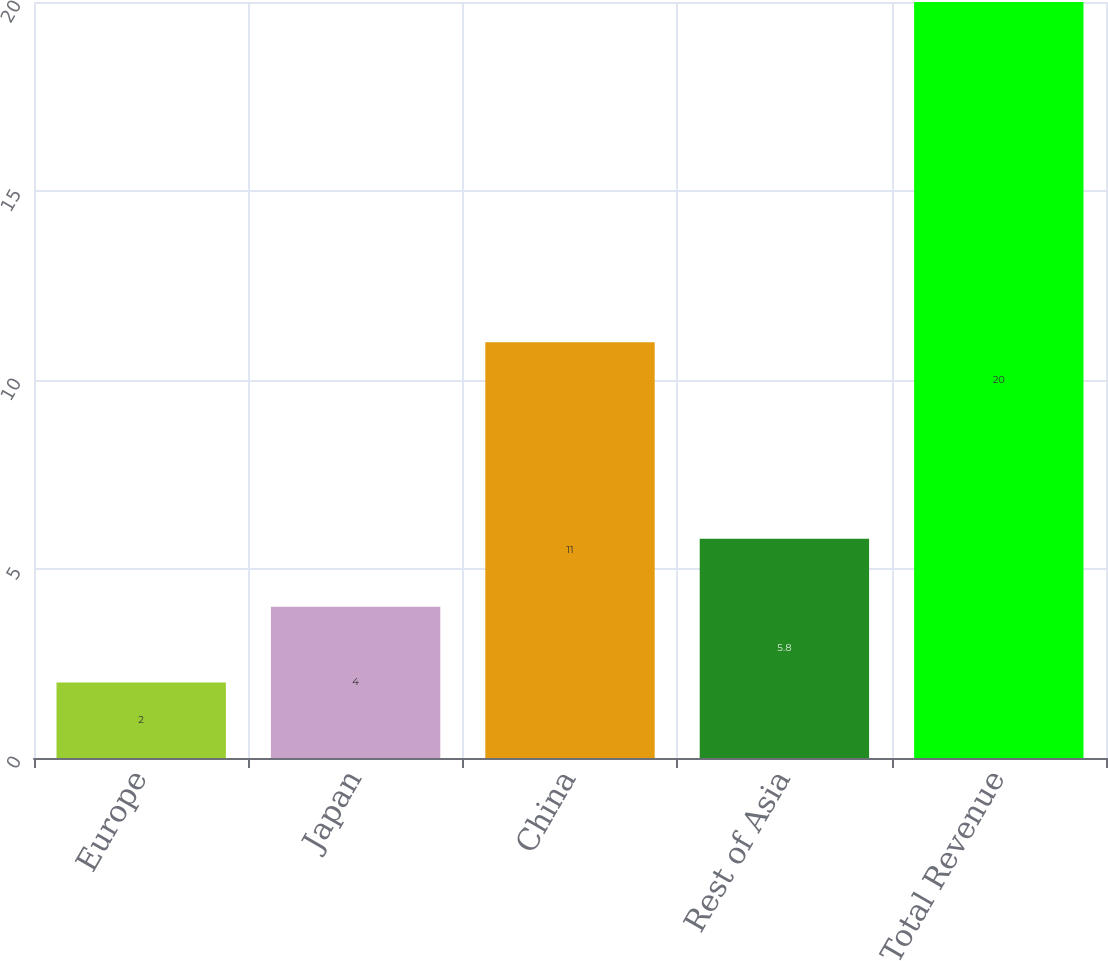Convert chart. <chart><loc_0><loc_0><loc_500><loc_500><bar_chart><fcel>Europe<fcel>Japan<fcel>China<fcel>Rest of Asia<fcel>Total Revenue<nl><fcel>2<fcel>4<fcel>11<fcel>5.8<fcel>20<nl></chart> 